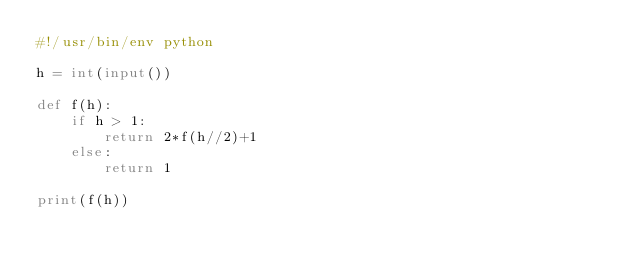Convert code to text. <code><loc_0><loc_0><loc_500><loc_500><_Python_>#!/usr/bin/env python

h = int(input())

def f(h):
    if h > 1:
        return 2*f(h//2)+1
    else:
        return 1

print(f(h))
</code> 